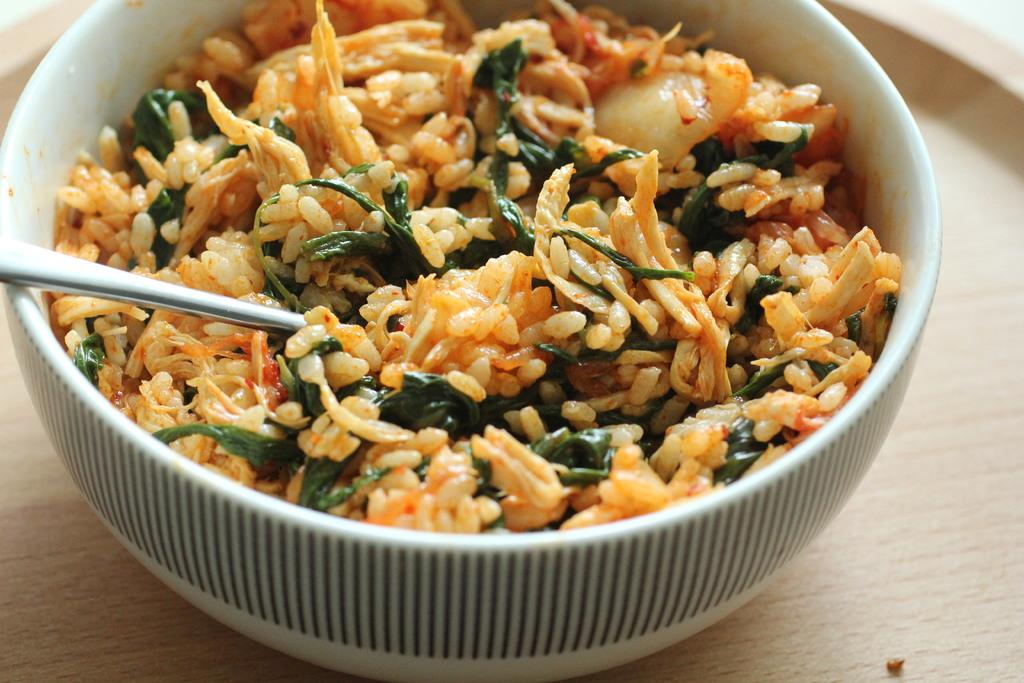What type of food is in the bowl in the image? There is rice with curry in the image. What utensil is in the bowl with the food? There is a spoon in the bowl. On what surface is the bowl placed? The bowl is on a wooden table. What type of fuel is being used to cook the curry in the image? There is no stove or fuel visible in the image, as it only shows a bowl of rice with curry on a wooden table. 